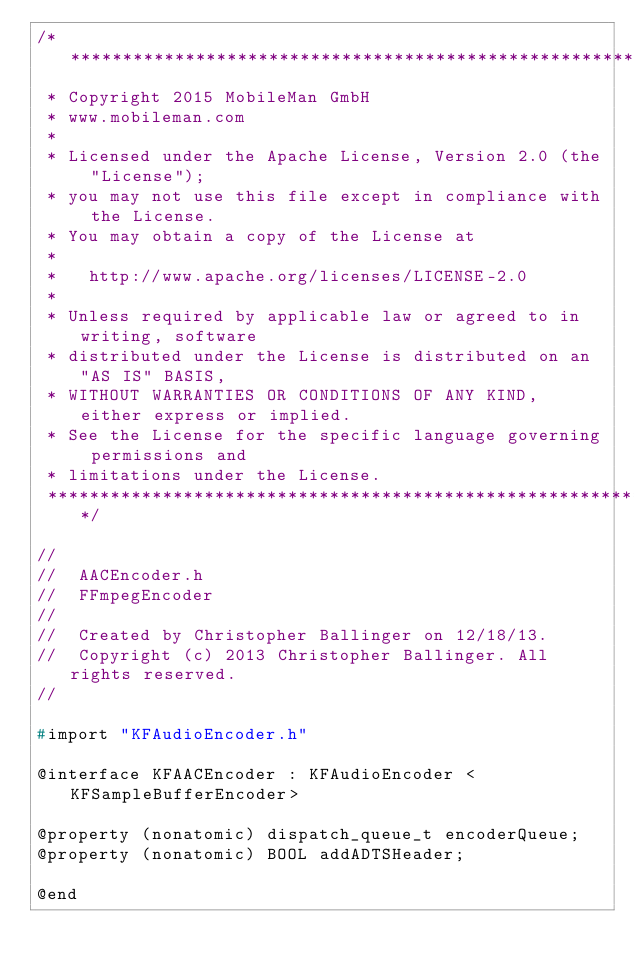<code> <loc_0><loc_0><loc_500><loc_500><_C_>/*******************************************************************************
 * Copyright 2015 MobileMan GmbH
 * www.mobileman.com
 * 
 * Licensed under the Apache License, Version 2.0 (the "License");
 * you may not use this file except in compliance with the License.
 * You may obtain a copy of the License at
 * 
 *   http://www.apache.org/licenses/LICENSE-2.0
 * 
 * Unless required by applicable law or agreed to in writing, software
 * distributed under the License is distributed on an "AS IS" BASIS,
 * WITHOUT WARRANTIES OR CONDITIONS OF ANY KIND, either express or implied.
 * See the License for the specific language governing permissions and
 * limitations under the License.
 ******************************************************************************/

//
//  AACEncoder.h
//  FFmpegEncoder
//
//  Created by Christopher Ballinger on 12/18/13.
//  Copyright (c) 2013 Christopher Ballinger. All rights reserved.
//

#import "KFAudioEncoder.h"

@interface KFAACEncoder : KFAudioEncoder <KFSampleBufferEncoder>

@property (nonatomic) dispatch_queue_t encoderQueue;
@property (nonatomic) BOOL addADTSHeader;

@end
</code> 